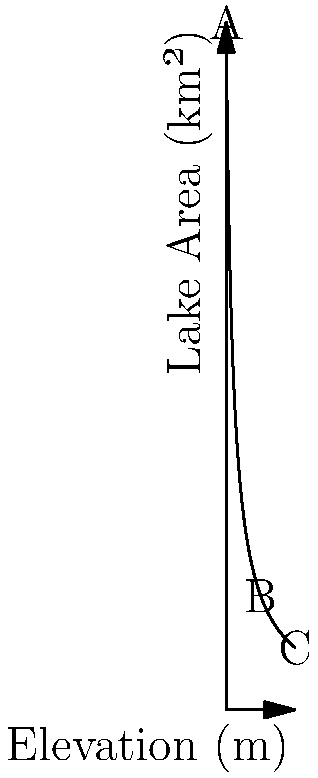During our hiking trip, we observed a lake from different elevations. The graph shows how the apparent area of the lake changes with elevation. If the lake appears to be 100 km² at ground level (0 m elevation), what is the rate of change of the lake's apparent area between 5 m and 10 m elevation? Let's approach this step-by-step:

1) The function describing the lake's apparent area $A$ in terms of elevation $h$ is:

   $$A(h) = \frac{100}{h+1}$$

2) We need to find the rate of change between 5 m and 10 m elevation.

3) Calculate the area at 5 m elevation:
   $$A(5) = \frac{100}{5+1} = \frac{100}{6} \approx 16.67 \text{ km²}$$

4) Calculate the area at 10 m elevation:
   $$A(10) = \frac{100}{10+1} = \frac{100}{11} \approx 9.09 \text{ km²}$$

5) The change in area is:
   $$\Delta A = A(5) - A(10) \approx 16.67 - 9.09 = 7.58 \text{ km²}$$

6) The change in elevation is:
   $$\Delta h = 10 - 5 = 5 \text{ m}$$

7) The rate of change is the change in area divided by the change in elevation:
   $$\text{Rate of change} = \frac{\Delta A}{\Delta h} = \frac{7.58}{5} \approx 1.52 \text{ km²/m}$$

Therefore, the rate of change of the lake's apparent area between 5 m and 10 m elevation is approximately 1.52 km² per meter.
Answer: 1.52 km²/m 